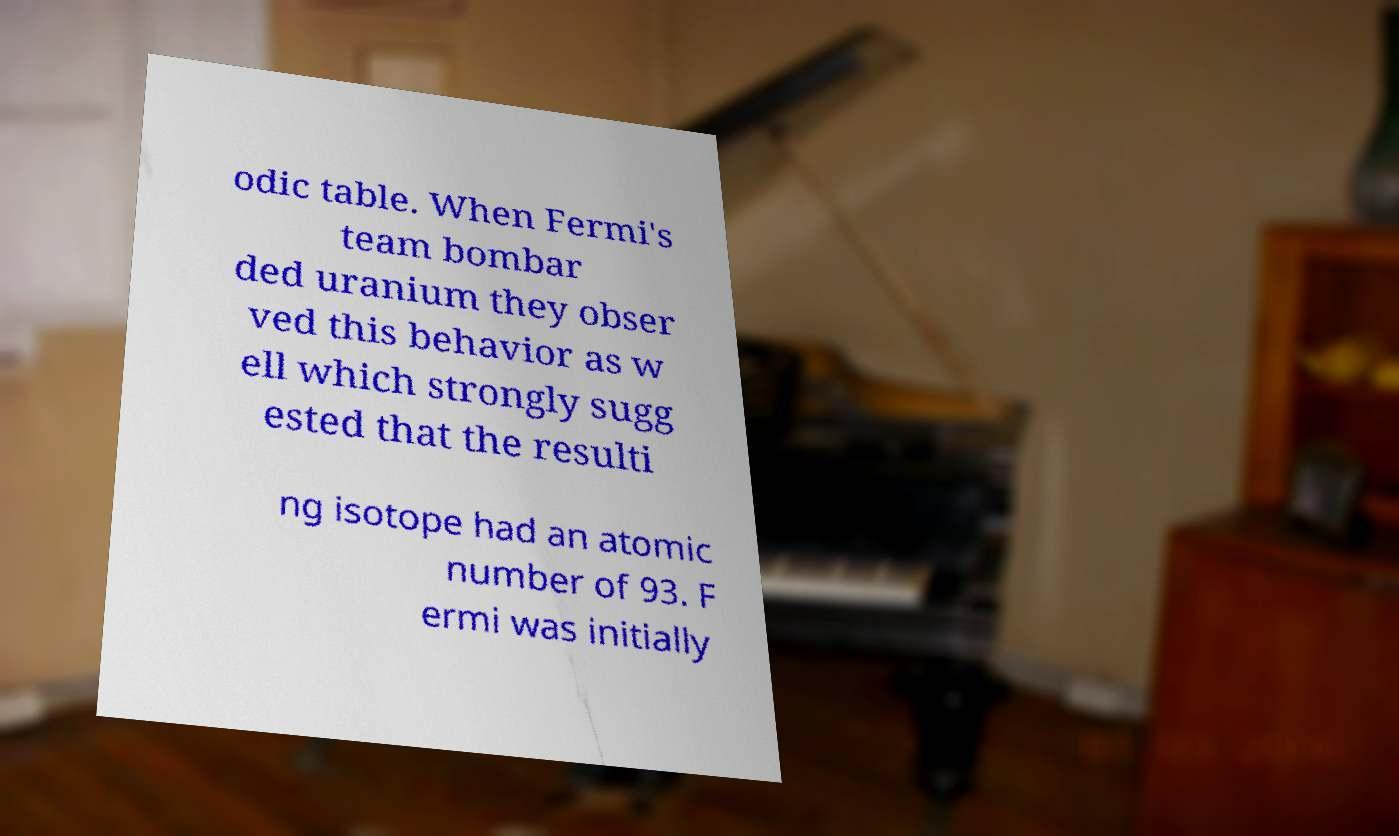I need the written content from this picture converted into text. Can you do that? odic table. When Fermi's team bombar ded uranium they obser ved this behavior as w ell which strongly sugg ested that the resulti ng isotope had an atomic number of 93. F ermi was initially 